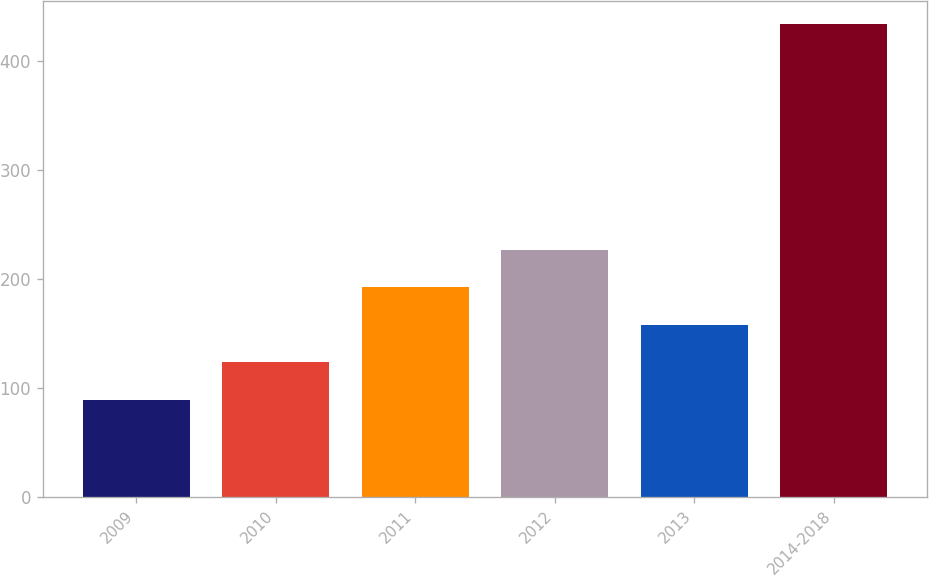Convert chart. <chart><loc_0><loc_0><loc_500><loc_500><bar_chart><fcel>2009<fcel>2010<fcel>2011<fcel>2012<fcel>2013<fcel>2014-2018<nl><fcel>89<fcel>123.5<fcel>192.5<fcel>227<fcel>158<fcel>434<nl></chart> 